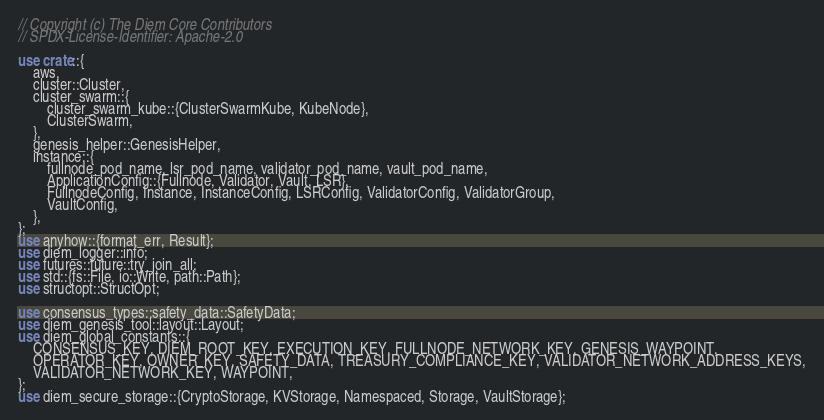Convert code to text. <code><loc_0><loc_0><loc_500><loc_500><_Rust_>// Copyright (c) The Diem Core Contributors
// SPDX-License-Identifier: Apache-2.0

use crate::{
    aws,
    cluster::Cluster,
    cluster_swarm::{
        cluster_swarm_kube::{ClusterSwarmKube, KubeNode},
        ClusterSwarm,
    },
    genesis_helper::GenesisHelper,
    instance::{
        fullnode_pod_name, lsr_pod_name, validator_pod_name, vault_pod_name,
        ApplicationConfig::{Fullnode, Validator, Vault, LSR},
        FullnodeConfig, Instance, InstanceConfig, LSRConfig, ValidatorConfig, ValidatorGroup,
        VaultConfig,
    },
};
use anyhow::{format_err, Result};
use diem_logger::info;
use futures::future::try_join_all;
use std::{fs::File, io::Write, path::Path};
use structopt::StructOpt;

use consensus_types::safety_data::SafetyData;
use diem_genesis_tool::layout::Layout;
use diem_global_constants::{
    CONSENSUS_KEY, DIEM_ROOT_KEY, EXECUTION_KEY, FULLNODE_NETWORK_KEY, GENESIS_WAYPOINT,
    OPERATOR_KEY, OWNER_KEY, SAFETY_DATA, TREASURY_COMPLIANCE_KEY, VALIDATOR_NETWORK_ADDRESS_KEYS,
    VALIDATOR_NETWORK_KEY, WAYPOINT,
};
use diem_secure_storage::{CryptoStorage, KVStorage, Namespaced, Storage, VaultStorage};</code> 